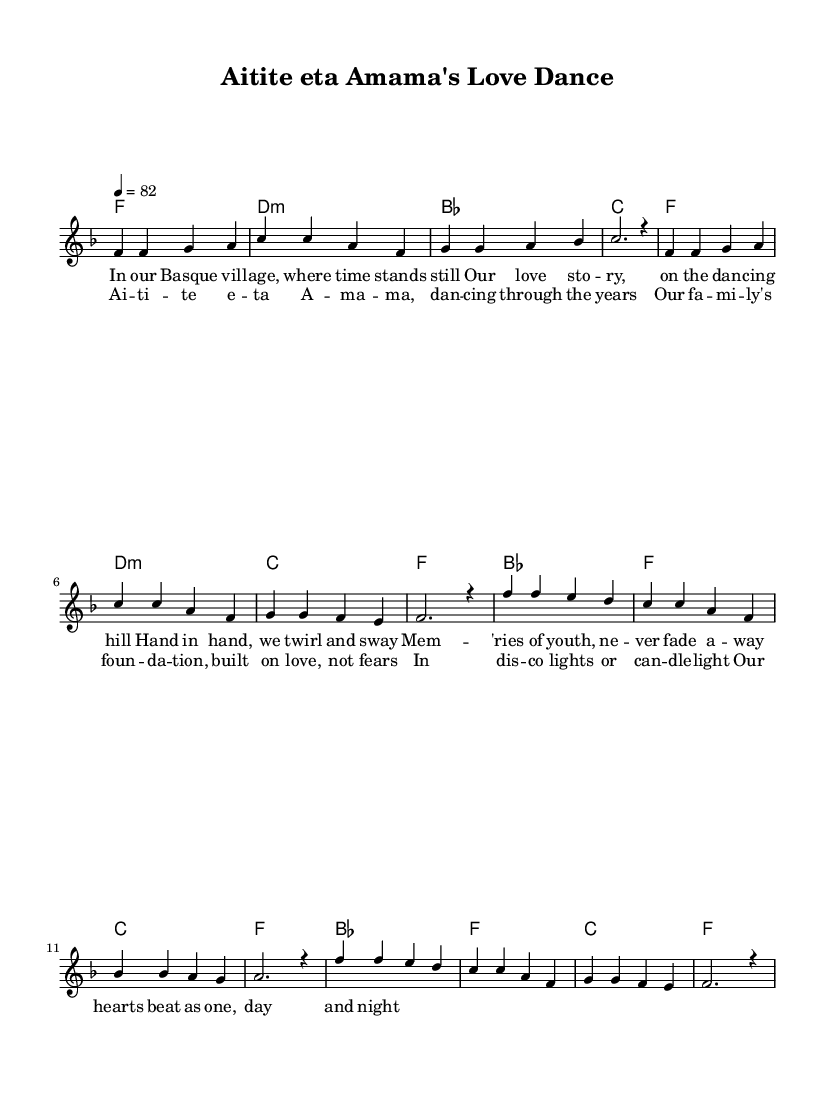What is the key signature of this music? The key signature indicates the tonal center of the piece. Here, it is denoted as 'f \major', which means that there is one flat (B flat) in the key signature.
Answer: F major What is the time signature of this music? The time signature is shown at the beginning of the sheet music as '4/4', meaning there are four beats in each measure and a quarter note receives one beat.
Answer: 4/4 What is the tempo marking for this piece? The tempo marking is shown in the score as '4 = 82', indicating that there are 82 beats per minute in the piece, which provides an idea of how fast the music should be played.
Answer: 82 How many measures are there in the melody section? By counting the distinct grouping of notes and rests within the melody, there are a total of 8 measures that make up the melody section.
Answer: 8 What is the main lyrical theme of this piece? The lyrics revolve around love, family, and creating memories, specifically celebrating familial bonds in a welcoming Basque community. The title also suggests a dance.
Answer: Love and family What kind of chords are used in the harmony section? The harmony section consists of a variety of chords including major and minor chords; common in disco music to create a rich and emotional sound. Specifically, it uses f, d minor, bes, and c chords.
Answer: Major and minor chords What is the relationship between the verse and chorus in this composition? The verse tells a story of love and dance, while the chorus emphasizes the importance of family and shared memories, enhancing the overall theme of unity and celebration, suitable for a disco ballad context.
Answer: Unity and celebration 